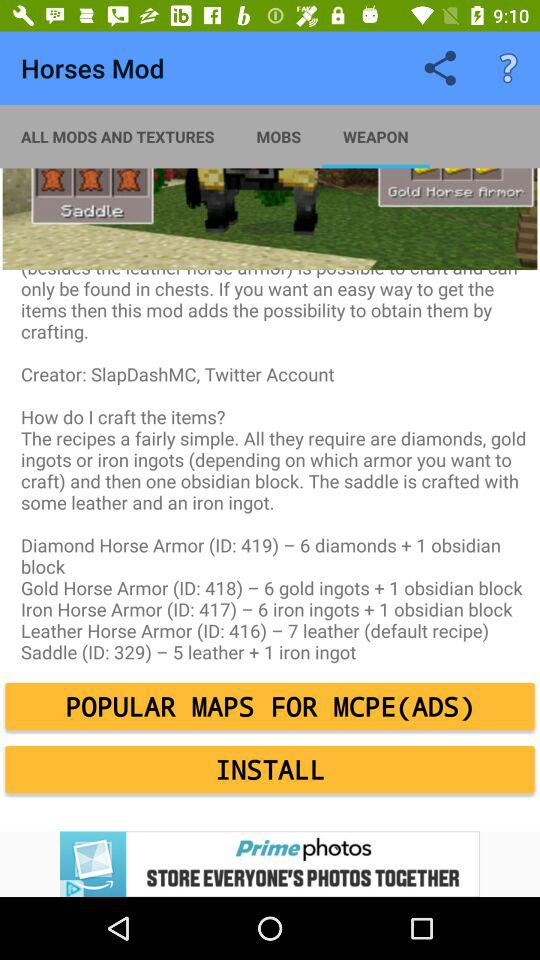How many diamonds are needed for the diamond horse armor?
Answer the question using a single word or phrase. 6 